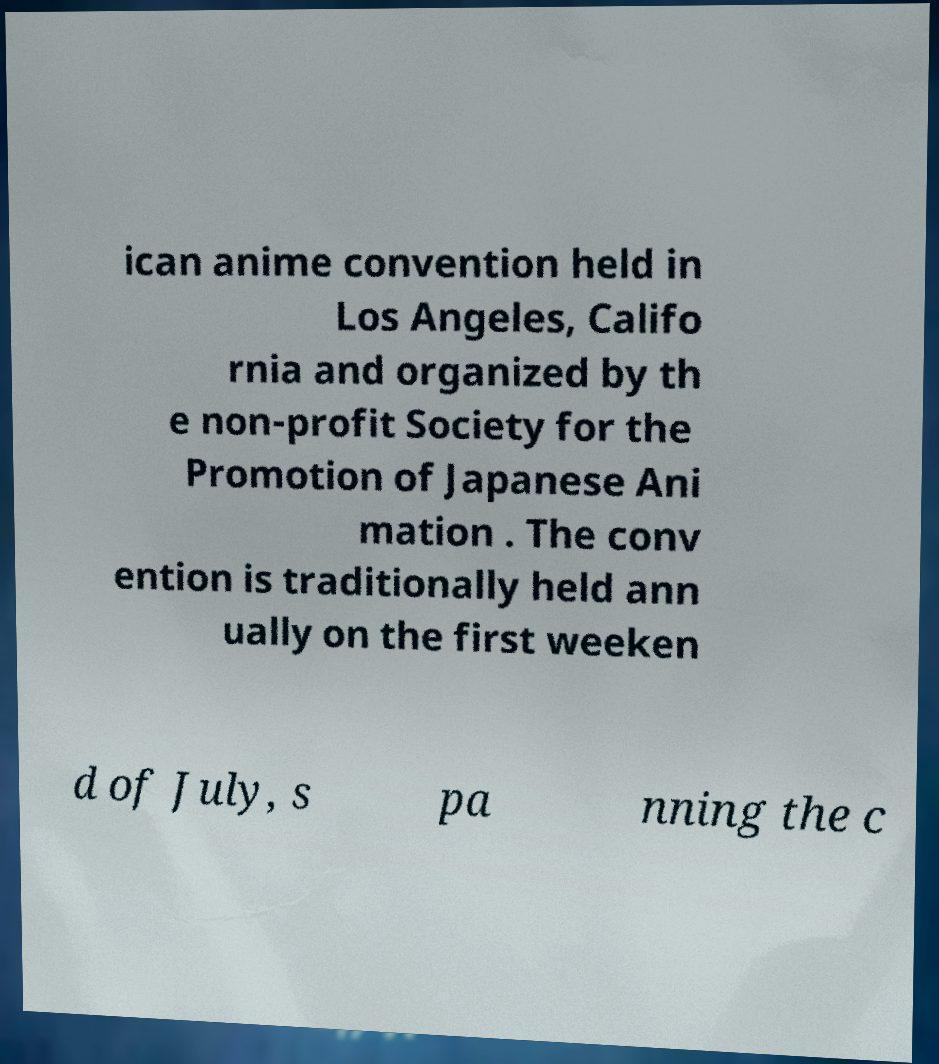Please read and relay the text visible in this image. What does it say? ican anime convention held in Los Angeles, Califo rnia and organized by th e non-profit Society for the Promotion of Japanese Ani mation . The conv ention is traditionally held ann ually on the first weeken d of July, s pa nning the c 